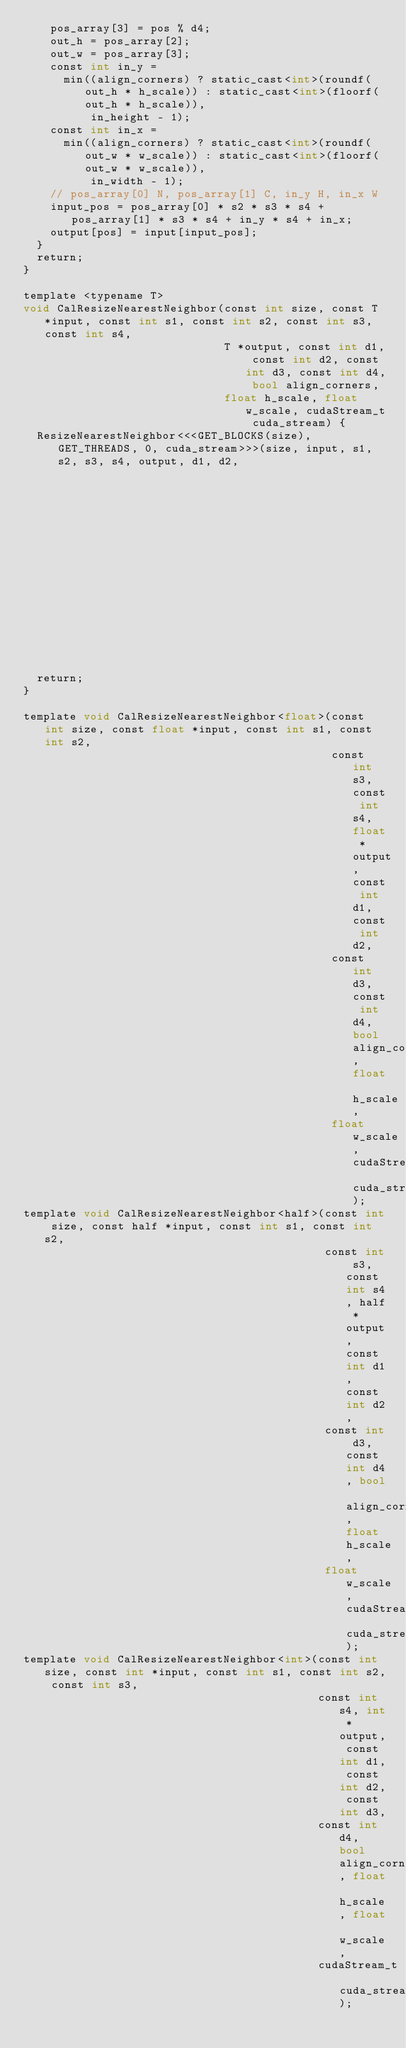<code> <loc_0><loc_0><loc_500><loc_500><_Cuda_>    pos_array[3] = pos % d4;
    out_h = pos_array[2];
    out_w = pos_array[3];
    const int in_y =
      min((align_corners) ? static_cast<int>(roundf(out_h * h_scale)) : static_cast<int>(floorf(out_h * h_scale)),
          in_height - 1);
    const int in_x =
      min((align_corners) ? static_cast<int>(roundf(out_w * w_scale)) : static_cast<int>(floorf(out_w * w_scale)),
          in_width - 1);
    // pos_array[0] N, pos_array[1] C, in_y H, in_x W
    input_pos = pos_array[0] * s2 * s3 * s4 + pos_array[1] * s3 * s4 + in_y * s4 + in_x;
    output[pos] = input[input_pos];
  }
  return;
}

template <typename T>
void CalResizeNearestNeighbor(const int size, const T *input, const int s1, const int s2, const int s3, const int s4,
                              T *output, const int d1, const int d2, const int d3, const int d4, bool align_corners,
                              float h_scale, float w_scale, cudaStream_t cuda_stream) {
  ResizeNearestNeighbor<<<GET_BLOCKS(size), GET_THREADS, 0, cuda_stream>>>(size, input, s1, s2, s3, s4, output, d1, d2,
                                                                           d3, d4, align_corners, h_scale, w_scale);
  return;
}

template void CalResizeNearestNeighbor<float>(const int size, const float *input, const int s1, const int s2,
                                              const int s3, const int s4, float *output, const int d1, const int d2,
                                              const int d3, const int d4, bool align_corners, float h_scale,
                                              float w_scale, cudaStream_t cuda_stream);
template void CalResizeNearestNeighbor<half>(const int size, const half *input, const int s1, const int s2,
                                             const int s3, const int s4, half *output, const int d1, const int d2,
                                             const int d3, const int d4, bool align_corners, float h_scale,
                                             float w_scale, cudaStream_t cuda_stream);
template void CalResizeNearestNeighbor<int>(const int size, const int *input, const int s1, const int s2, const int s3,
                                            const int s4, int *output, const int d1, const int d2, const int d3,
                                            const int d4, bool align_corners, float h_scale, float w_scale,
                                            cudaStream_t cuda_stream);
</code> 